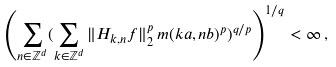<formula> <loc_0><loc_0><loc_500><loc_500>\left ( \sum _ { n \in \mathbb { Z } ^ { d } } ( \sum _ { k \in \mathbb { Z } ^ { d } } \| H _ { k , n } f \| ^ { p } _ { 2 } \, m ( k a , n b ) ^ { p } ) ^ { q / p } \right ) ^ { 1 / q } < \infty \, ,</formula> 